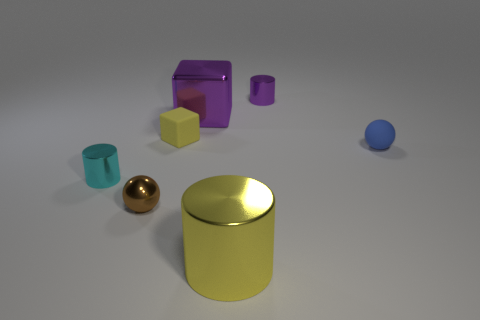Add 1 big yellow things. How many objects exist? 8 Subtract all cylinders. How many objects are left? 4 Subtract 0 brown cubes. How many objects are left? 7 Subtract all blue matte objects. Subtract all large rubber balls. How many objects are left? 6 Add 5 matte spheres. How many matte spheres are left? 6 Add 2 big purple shiny cubes. How many big purple shiny cubes exist? 3 